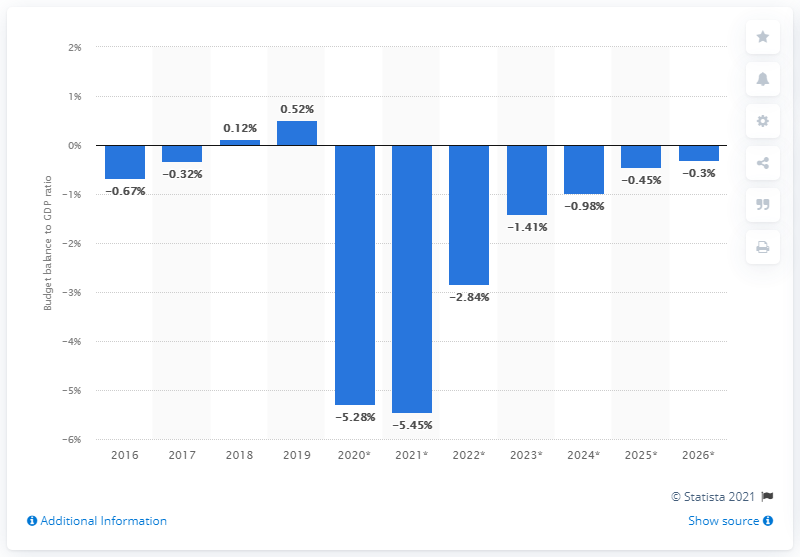Draw attention to some important aspects in this diagram. In 2019, the state surplus accounted for 0.52% of Ireland's GDP. 